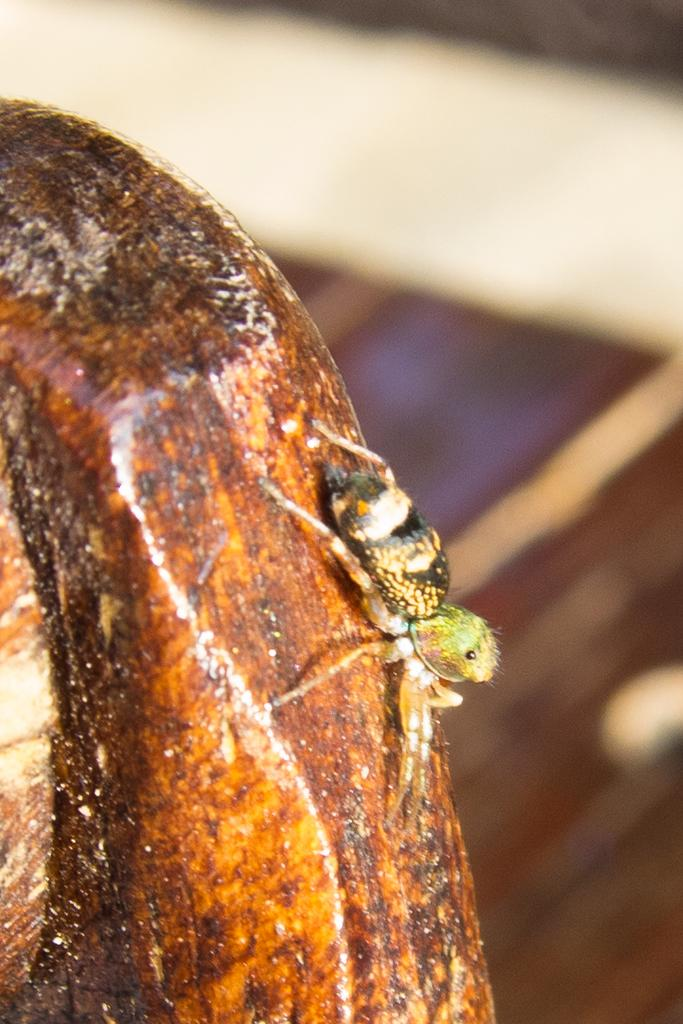What is present in the image? There is an insect in the image. Where is the insect located? The insect is on a piece of wood. Can you describe the background of the image? The background of the image is blurred. How many eyes does the insect have in the image? The number of eyes the insect has cannot be determined from the image, as the insect's eyes are not visible. 